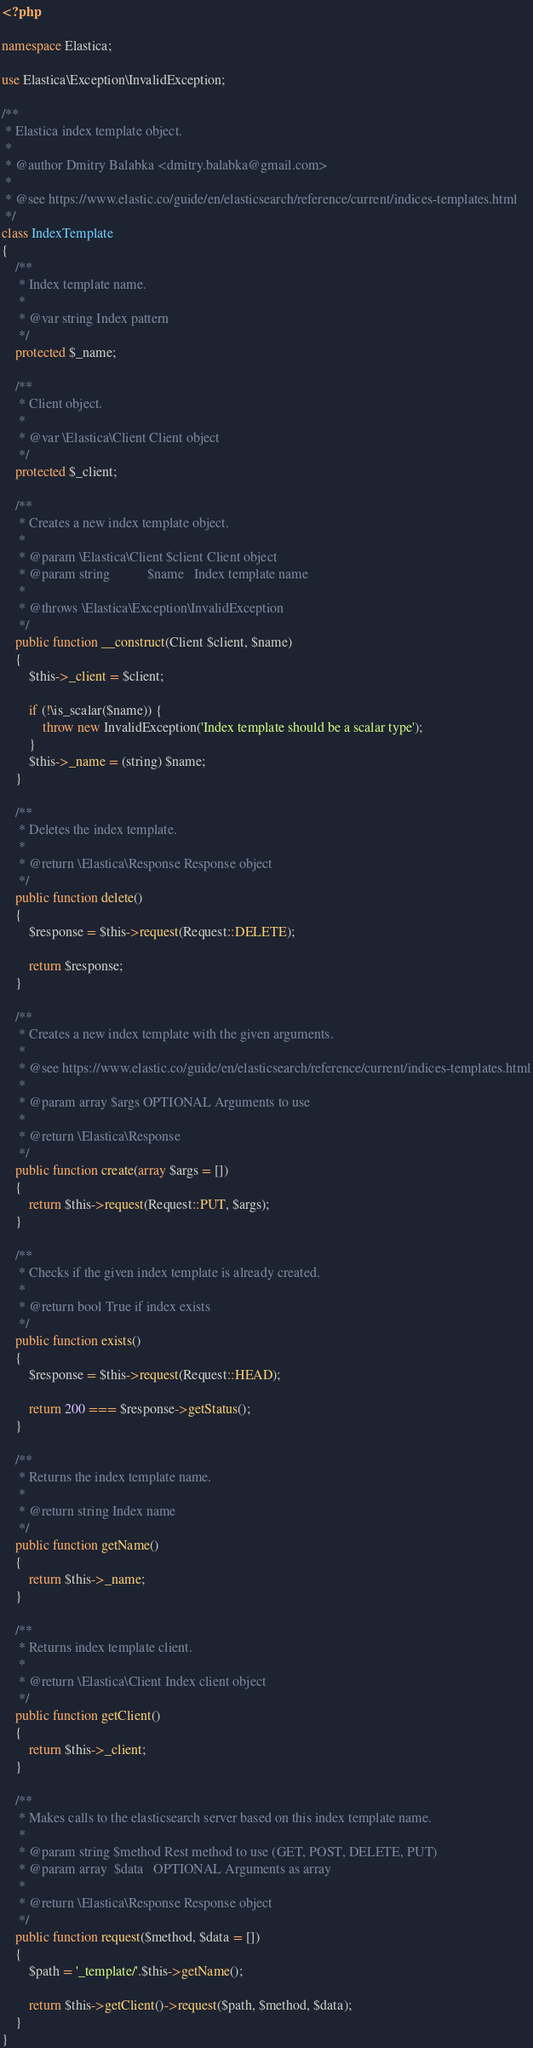Convert code to text. <code><loc_0><loc_0><loc_500><loc_500><_PHP_><?php

namespace Elastica;

use Elastica\Exception\InvalidException;

/**
 * Elastica index template object.
 *
 * @author Dmitry Balabka <dmitry.balabka@gmail.com>
 *
 * @see https://www.elastic.co/guide/en/elasticsearch/reference/current/indices-templates.html
 */
class IndexTemplate
{
    /**
     * Index template name.
     *
     * @var string Index pattern
     */
    protected $_name;

    /**
     * Client object.
     *
     * @var \Elastica\Client Client object
     */
    protected $_client;

    /**
     * Creates a new index template object.
     *
     * @param \Elastica\Client $client Client object
     * @param string           $name   Index template name
     *
     * @throws \Elastica\Exception\InvalidException
     */
    public function __construct(Client $client, $name)
    {
        $this->_client = $client;

        if (!\is_scalar($name)) {
            throw new InvalidException('Index template should be a scalar type');
        }
        $this->_name = (string) $name;
    }

    /**
     * Deletes the index template.
     *
     * @return \Elastica\Response Response object
     */
    public function delete()
    {
        $response = $this->request(Request::DELETE);

        return $response;
    }

    /**
     * Creates a new index template with the given arguments.
     *
     * @see https://www.elastic.co/guide/en/elasticsearch/reference/current/indices-templates.html
     *
     * @param array $args OPTIONAL Arguments to use
     *
     * @return \Elastica\Response
     */
    public function create(array $args = [])
    {
        return $this->request(Request::PUT, $args);
    }

    /**
     * Checks if the given index template is already created.
     *
     * @return bool True if index exists
     */
    public function exists()
    {
        $response = $this->request(Request::HEAD);

        return 200 === $response->getStatus();
    }

    /**
     * Returns the index template name.
     *
     * @return string Index name
     */
    public function getName()
    {
        return $this->_name;
    }

    /**
     * Returns index template client.
     *
     * @return \Elastica\Client Index client object
     */
    public function getClient()
    {
        return $this->_client;
    }

    /**
     * Makes calls to the elasticsearch server based on this index template name.
     *
     * @param string $method Rest method to use (GET, POST, DELETE, PUT)
     * @param array  $data   OPTIONAL Arguments as array
     *
     * @return \Elastica\Response Response object
     */
    public function request($method, $data = [])
    {
        $path = '_template/'.$this->getName();

        return $this->getClient()->request($path, $method, $data);
    }
}
</code> 